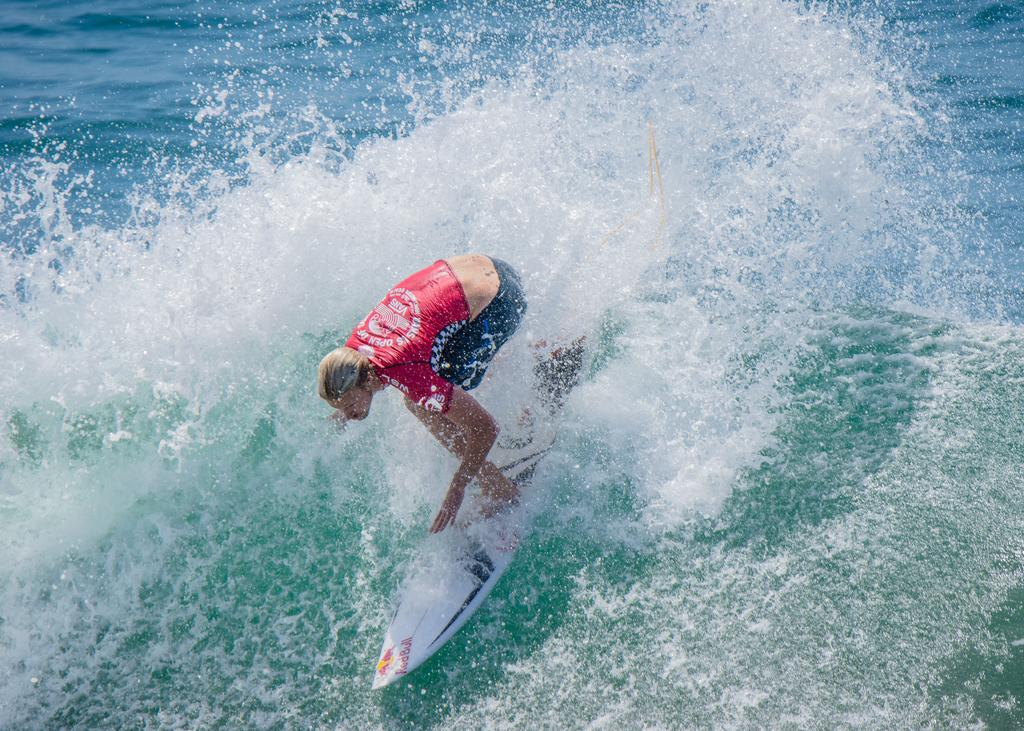What is the main subject of the image? There is a person in the image. What type of clothing is the person wearing? The person is wearing a t-shirt and shorts. What activity is the person engaged in? The person is surfing a board. Where is the board located? The board is on the water. What time is it in the image? The provided facts do not include any information about the time, so it cannot be determined from the image. How many minutes does it take for the monkey to complete the surfing session? There is no monkey present in the image, so it cannot be determined how long it takes for a monkey to complete a surfing session. 